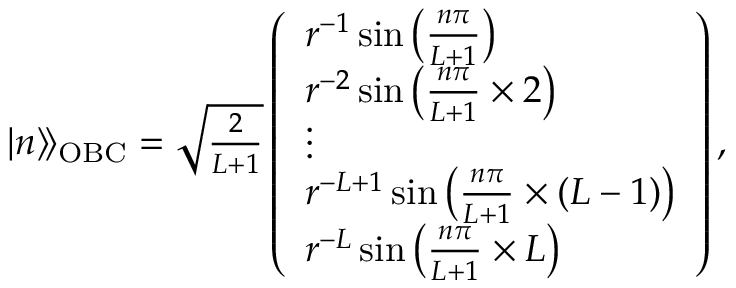Convert formula to latex. <formula><loc_0><loc_0><loc_500><loc_500>\begin{array} { r } { | n \rangle \, \rangle _ { O B C } = \sqrt { \frac { 2 } { L + 1 } } \left ( \begin{array} { l } { r ^ { - 1 } \sin { \left ( \frac { n \pi } { L + 1 } \right ) } } \\ { r ^ { - 2 } \sin { \left ( \frac { n \pi } { L + 1 } \times 2 \right ) } } \\ { \vdots } \\ { r ^ { - L + 1 } \sin { \left ( \frac { n \pi } { L + 1 } \times ( L - 1 ) \right ) } } \\ { r ^ { - L } \sin { \left ( \frac { n \pi } { L + 1 } \times L \right ) } } \end{array} \right ) , } \end{array}</formula> 